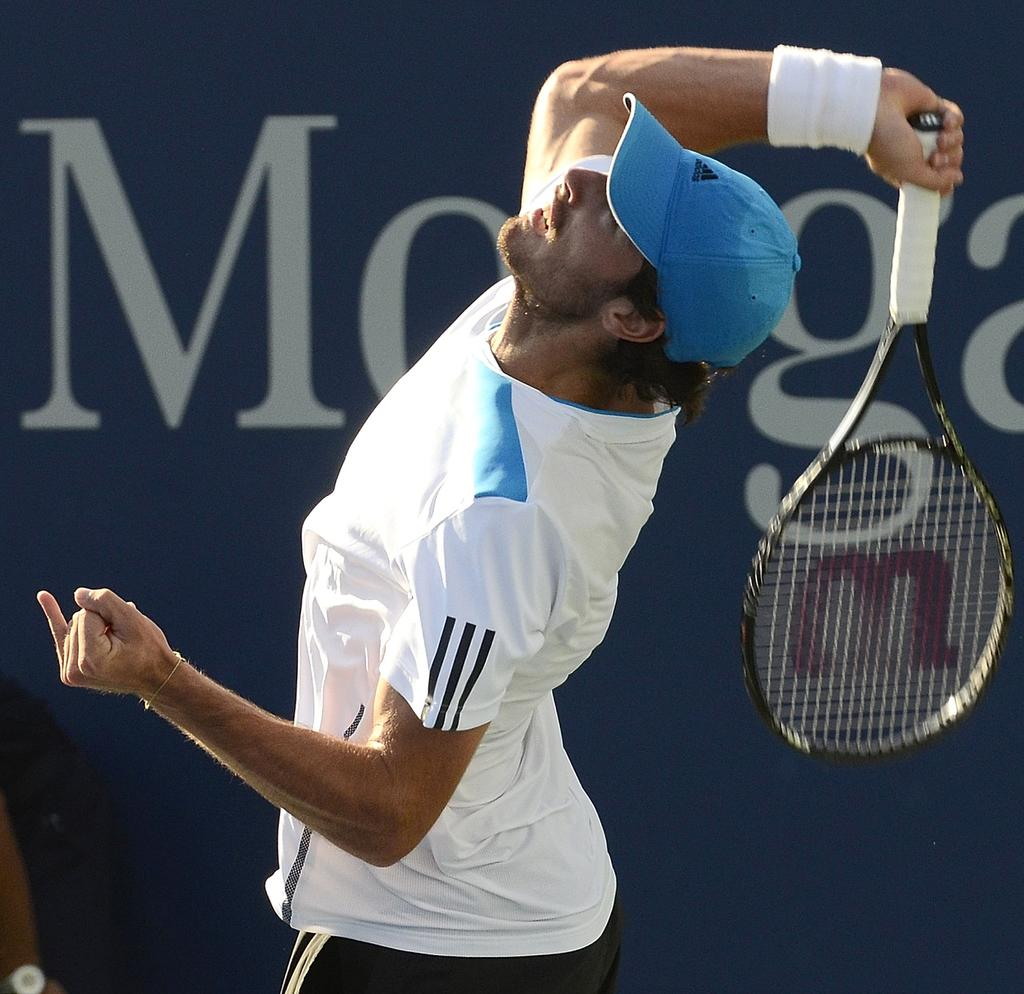Who is present in the image? There is a man in the image. What is the man wearing on his head? The man is wearing a cap. What object is the man holding in his hand? The man is holding a bat in his hand. What type of fowl can be seen in the image? There is no fowl present in the image; it features a man wearing a cap and holding a bat. Is there a woman in the image? No, there is no woman in the image; it features a man. 